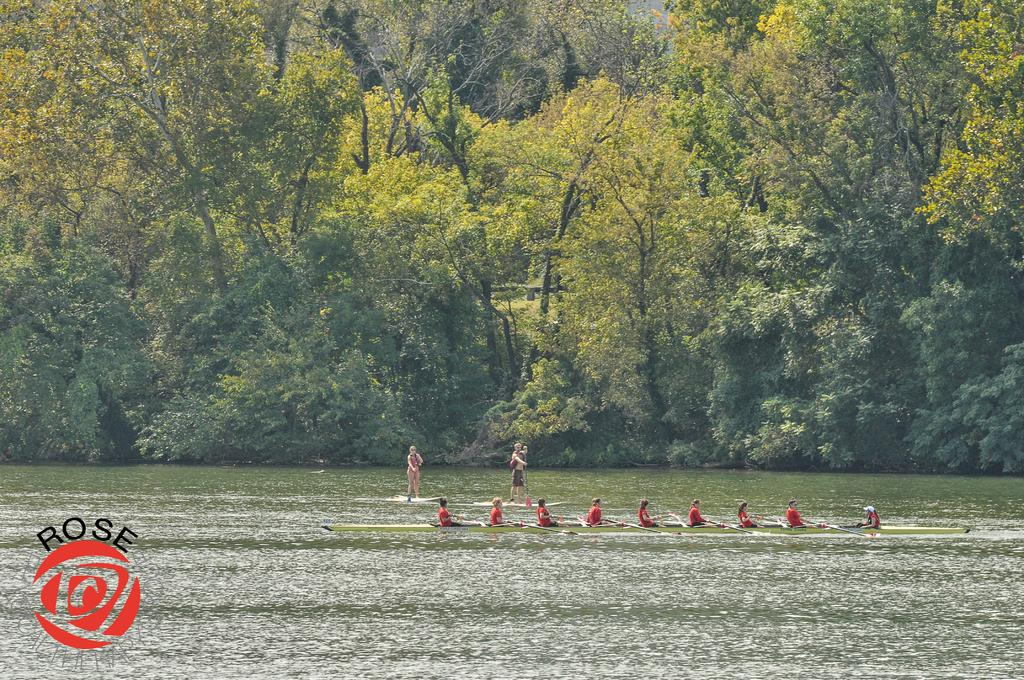What are the persons in the image doing? The persons in the image are sitting or standing on kayak boats. What are the persons holding in their hands? The persons are holding rows in their hands. What can be seen in the background of the image? There are trees in the background of the image. How does the trick performed by the man affect the rainstorm in the image? There is no man performing a trick, nor is there a rainstorm present in the image. 